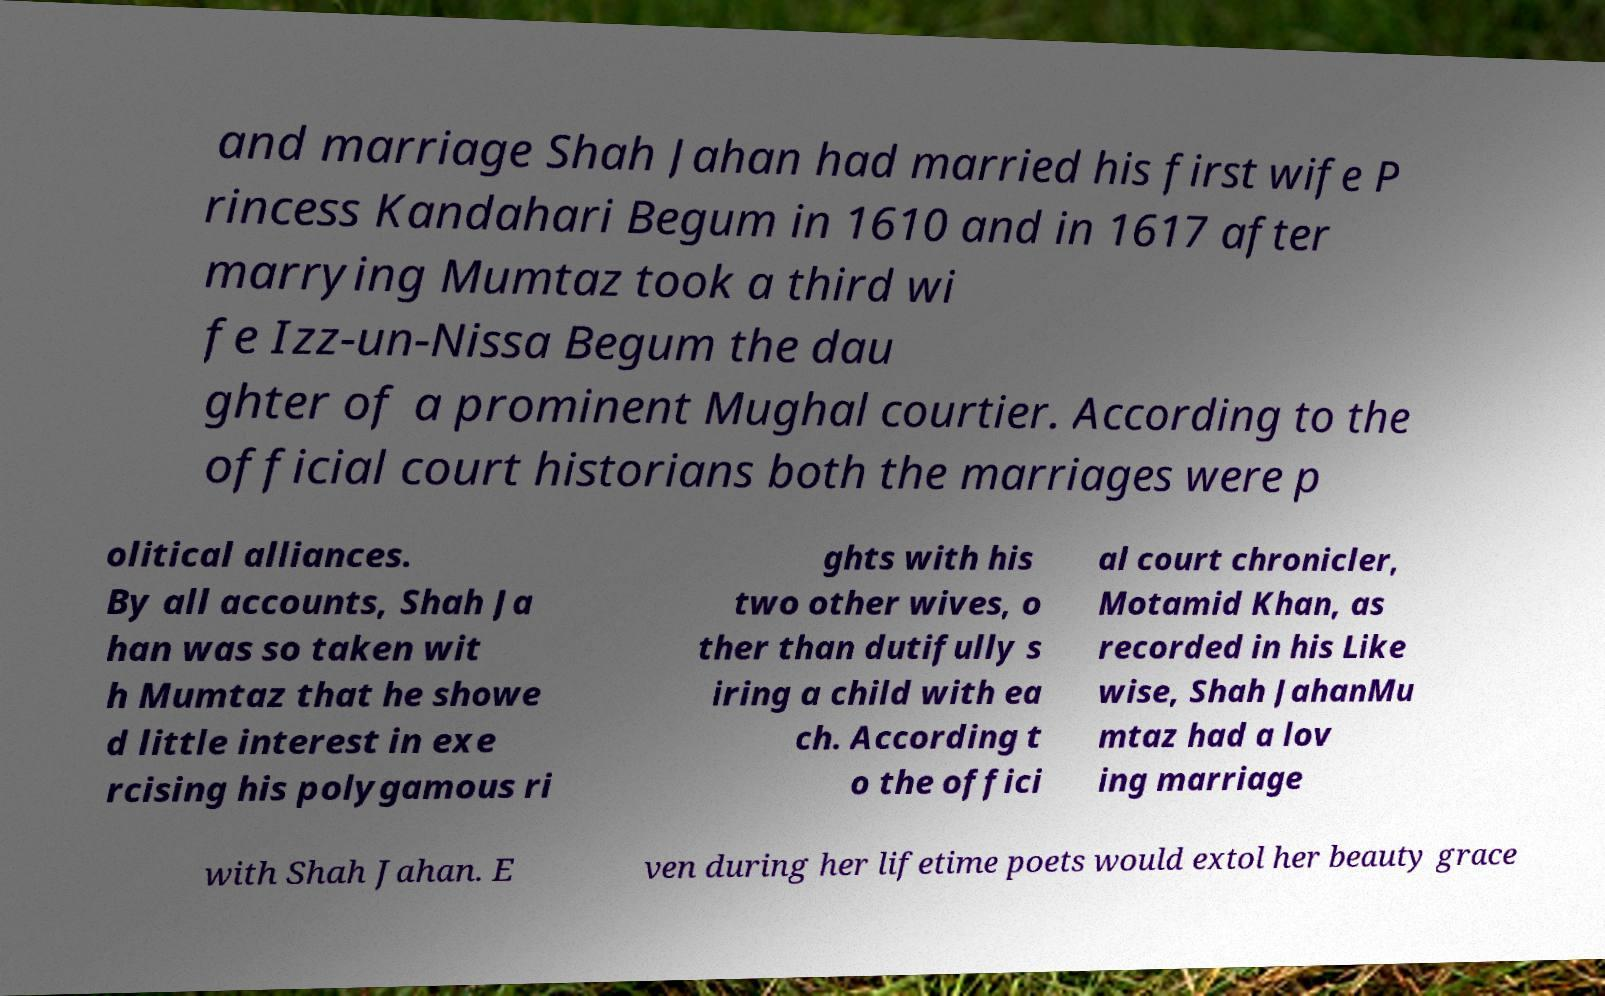I need the written content from this picture converted into text. Can you do that? and marriage Shah Jahan had married his first wife P rincess Kandahari Begum in 1610 and in 1617 after marrying Mumtaz took a third wi fe Izz-un-Nissa Begum the dau ghter of a prominent Mughal courtier. According to the official court historians both the marriages were p olitical alliances. By all accounts, Shah Ja han was so taken wit h Mumtaz that he showe d little interest in exe rcising his polygamous ri ghts with his two other wives, o ther than dutifully s iring a child with ea ch. According t o the offici al court chronicler, Motamid Khan, as recorded in his Like wise, Shah JahanMu mtaz had a lov ing marriage with Shah Jahan. E ven during her lifetime poets would extol her beauty grace 